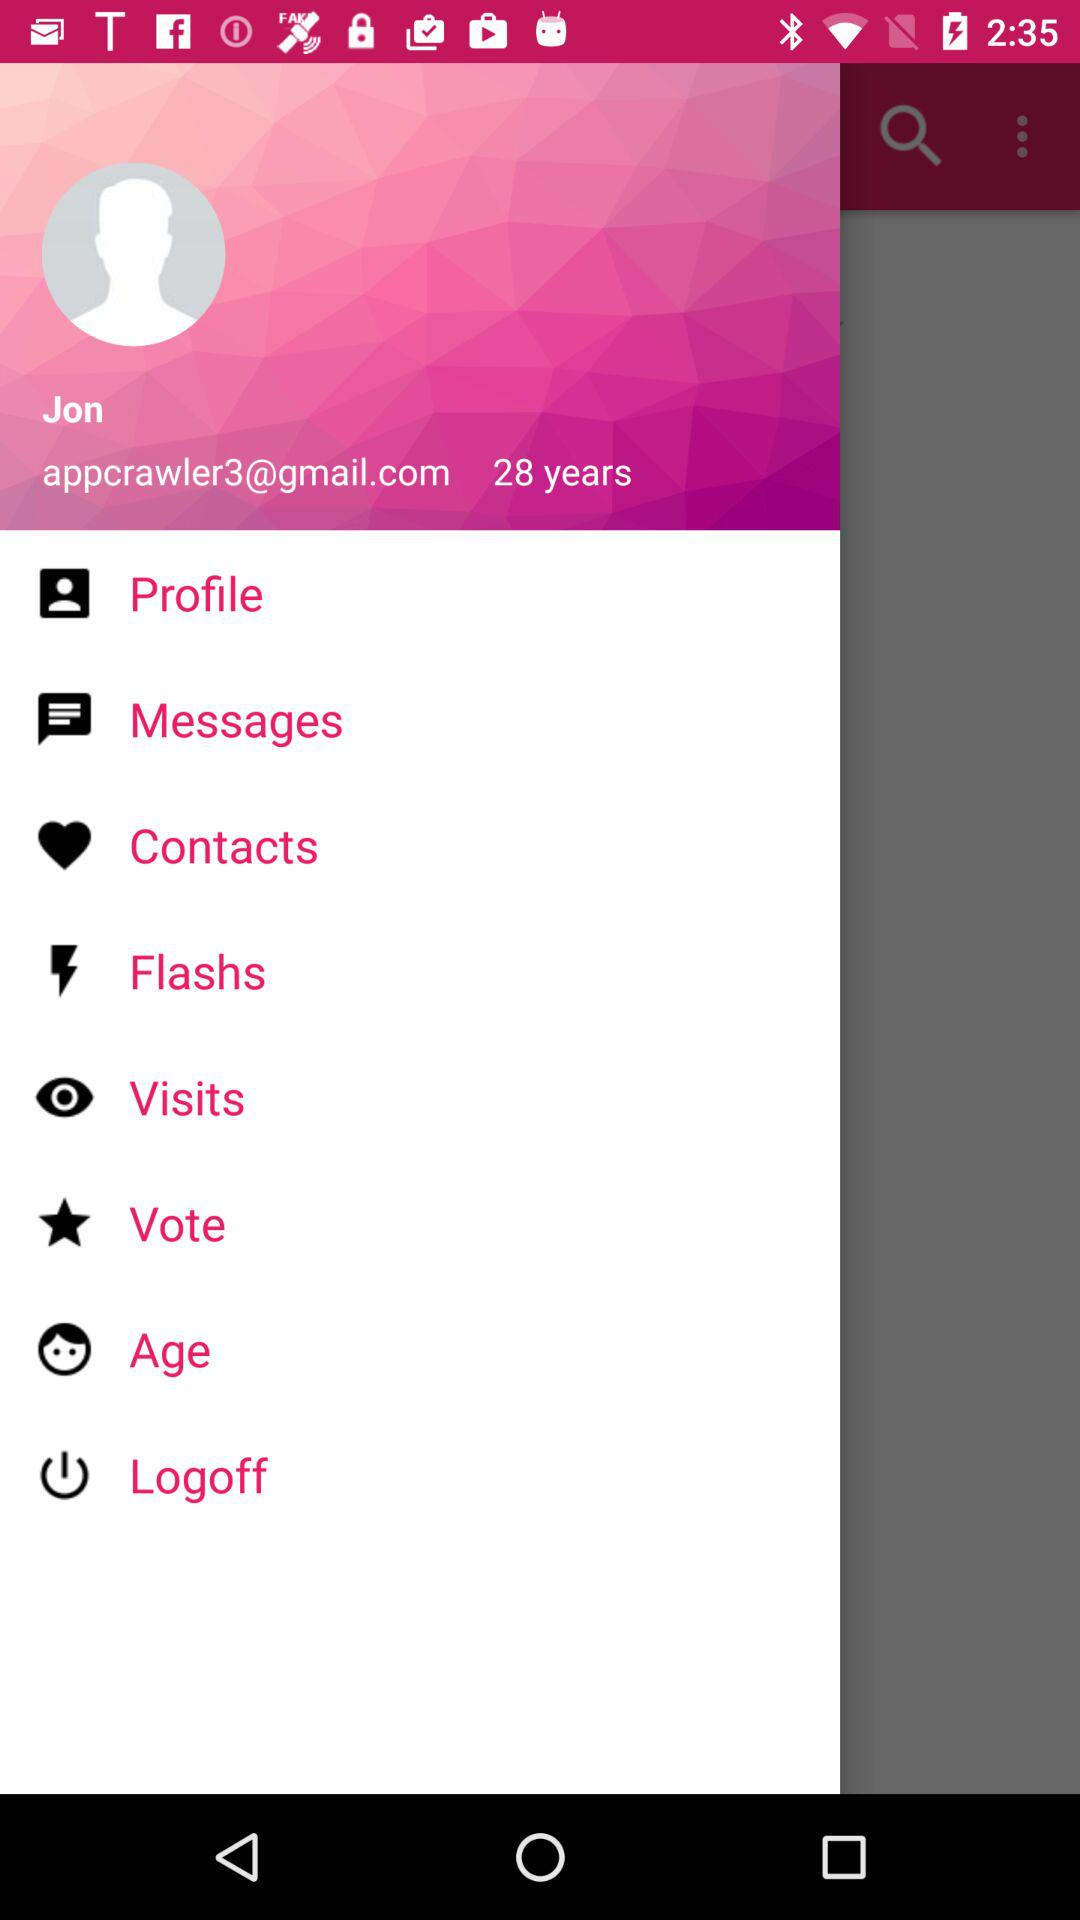How old is the user? The user is 28 years old. 